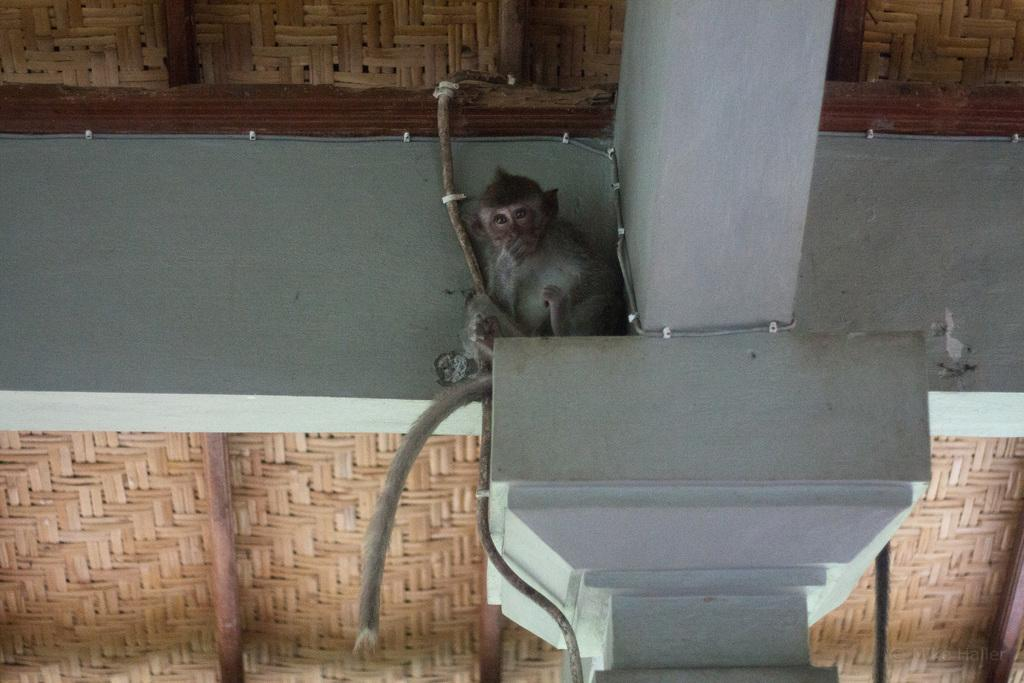What animal can be seen in the image? There is a monkey in the image. Where is the monkey located? The monkey is on a pillar. What objects are present in the image besides the monkey? There are wooden sticks in the image. What type of structure is visible in the image? There is a roof in the image. What type of zebra can be seen digesting food in the image? There is no zebra present in the image, and therefore no such activity can be observed. 